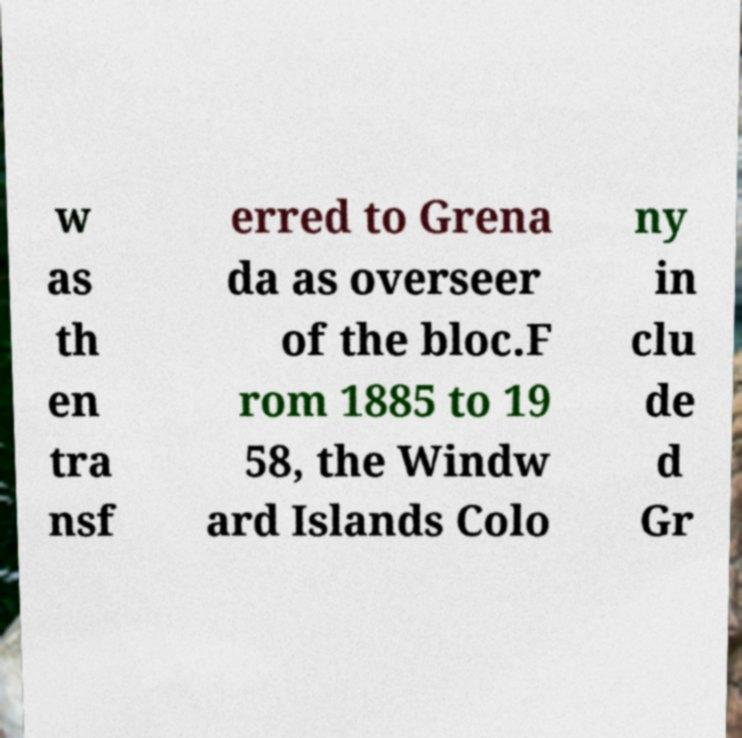Could you extract and type out the text from this image? w as th en tra nsf erred to Grena da as overseer of the bloc.F rom 1885 to 19 58, the Windw ard Islands Colo ny in clu de d Gr 